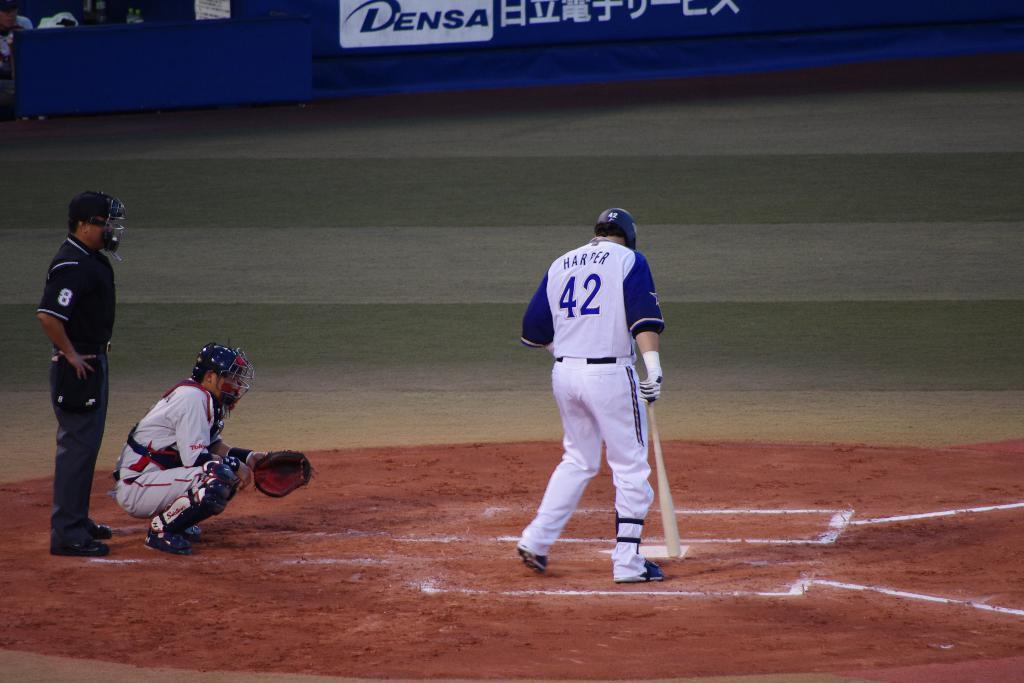Describe this image in one or two sentences. In the picture I can see a baseball player standing on the ground and he is holding the baseball stick in his right hand. There is a helmet on his head. There is a man on the left side. He is holding a glove in his left hand and there is a helmet on his head. I can see another man on the extreme left side is wearing a black color T-shirt and he is also wearing a helmet. There is a man on the top left side of the picture. I can see the hoarding at the top of the picture. 